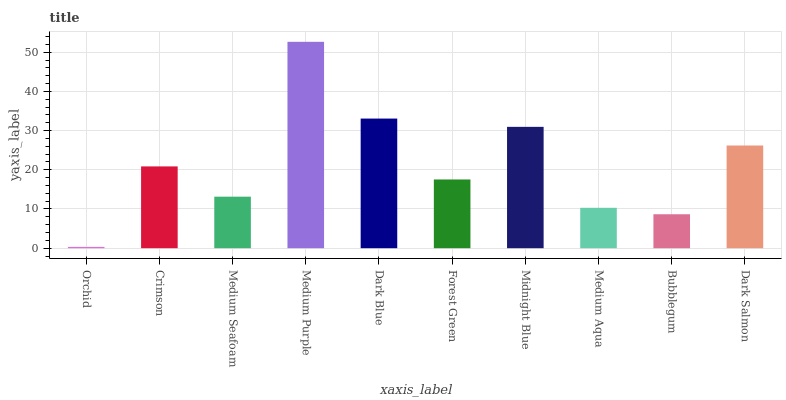Is Orchid the minimum?
Answer yes or no. Yes. Is Medium Purple the maximum?
Answer yes or no. Yes. Is Crimson the minimum?
Answer yes or no. No. Is Crimson the maximum?
Answer yes or no. No. Is Crimson greater than Orchid?
Answer yes or no. Yes. Is Orchid less than Crimson?
Answer yes or no. Yes. Is Orchid greater than Crimson?
Answer yes or no. No. Is Crimson less than Orchid?
Answer yes or no. No. Is Crimson the high median?
Answer yes or no. Yes. Is Forest Green the low median?
Answer yes or no. Yes. Is Midnight Blue the high median?
Answer yes or no. No. Is Crimson the low median?
Answer yes or no. No. 